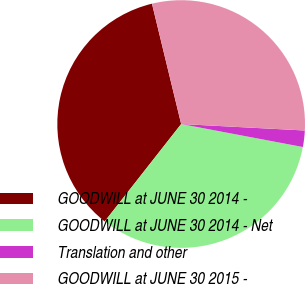Convert chart. <chart><loc_0><loc_0><loc_500><loc_500><pie_chart><fcel>GOODWILL at JUNE 30 2014 -<fcel>GOODWILL at JUNE 30 2014 - Net<fcel>Translation and other<fcel>GOODWILL at JUNE 30 2015 -<nl><fcel>35.62%<fcel>32.62%<fcel>2.14%<fcel>29.62%<nl></chart> 